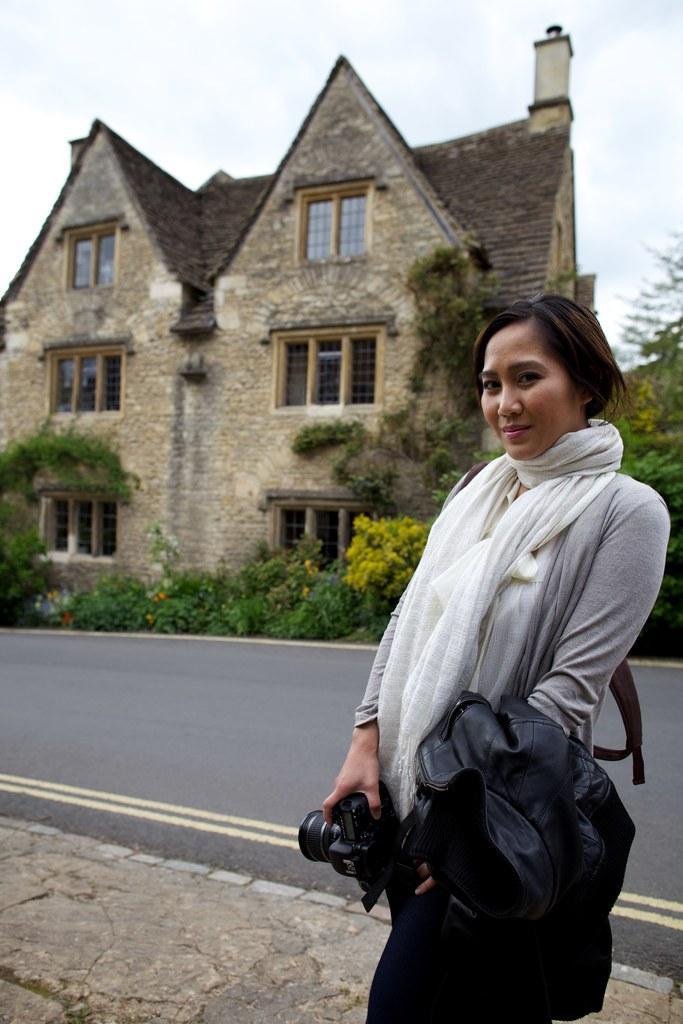Can you describe this image briefly? In the picture we can see a woman standing on the path and holding some clothes and camera in her hand, and she is smiling, in background we can see a road, house and plants on it, and we can also see a sky. 